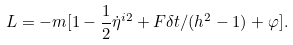<formula> <loc_0><loc_0><loc_500><loc_500>L = - m [ 1 - \frac { 1 } { 2 } \dot { \eta } ^ { i 2 } + F \delta t / ( h ^ { 2 } - 1 ) + \varphi ] .</formula> 